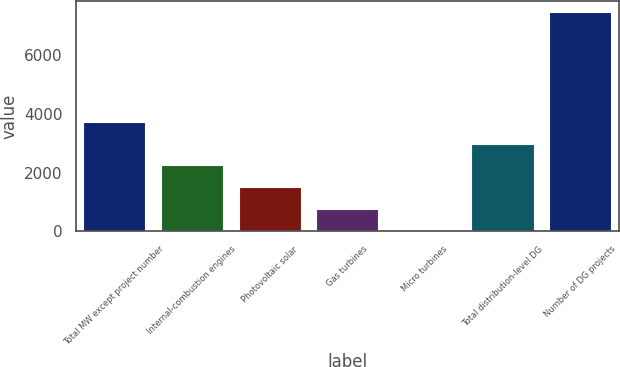Convert chart. <chart><loc_0><loc_0><loc_500><loc_500><bar_chart><fcel>Total MW except project number<fcel>Internal-combustion engines<fcel>Photovoltaic solar<fcel>Gas turbines<fcel>Micro turbines<fcel>Total distribution-level DG<fcel>Number of DG projects<nl><fcel>3730.5<fcel>2242.3<fcel>1498.2<fcel>754.1<fcel>10<fcel>2986.4<fcel>7451<nl></chart> 